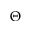Convert formula to latex. <formula><loc_0><loc_0><loc_500><loc_500>\Theta</formula> 